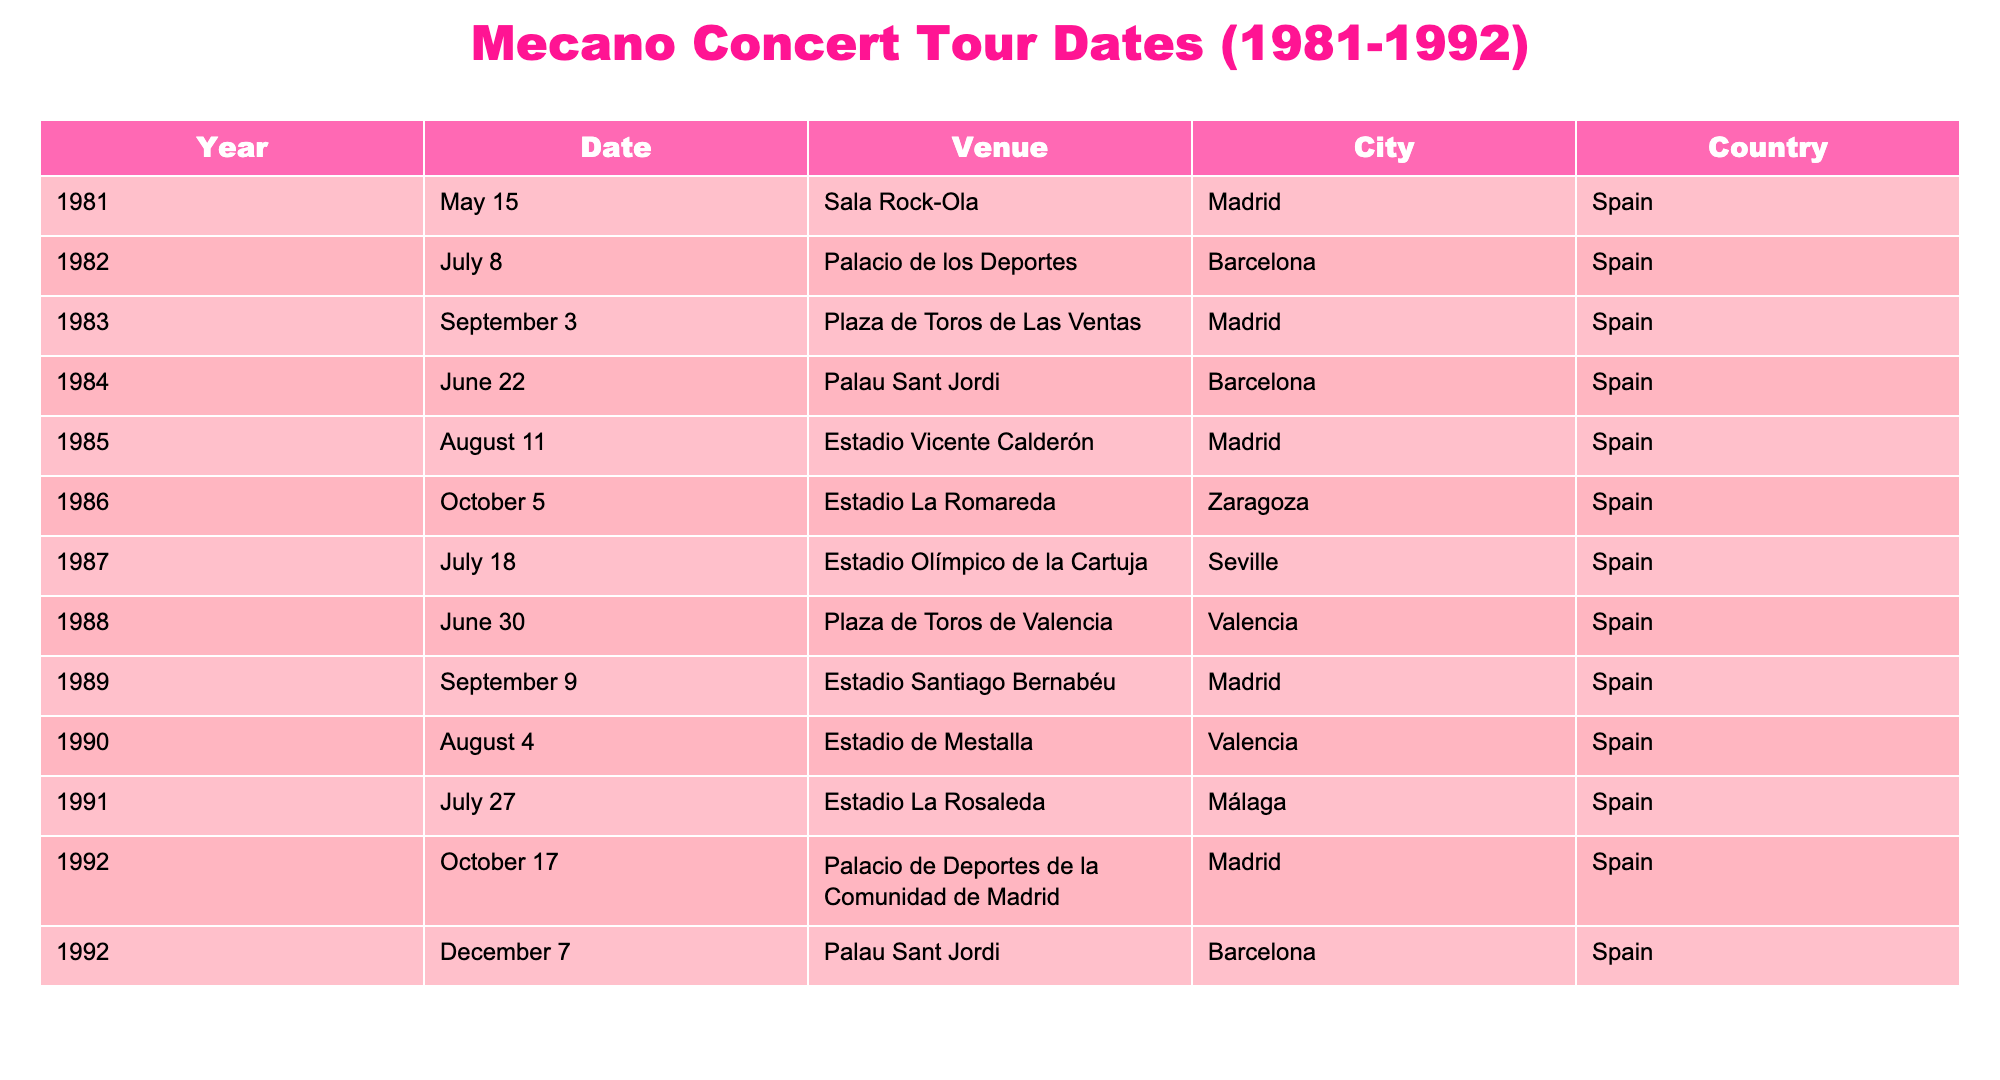What year did Mecano perform at Estadio Vicente Calderón? According to the table, Mecano performed at Estadio Vicente Calderón in 1985, as indicated in the row containing Venue details for that year.
Answer: 1985 Which city hosted the first concert in 1982? Referring to the table, the first concert in 1982 took place in Barcelona, as seen in the row for that year.
Answer: Barcelona How many concerts did Mecano have in Madrid from 1981 to 1992? By checking the table for rows that list Madrid as the city, we find concerts in 1981, 1983, 1985, 1989, and 1992, totaling five concerts.
Answer: 5 Did Mecano perform in Seville in 1987? Looking at the year 1987 in the table, it confirms that Mecano did indeed perform in Seville, as the entry for that year specifies the venue as Estadio Olímpico de la Cartuja in the city of Seville.
Answer: Yes What was the latest concert venue for Mecano in 1992? In the year 1992, the latest concert venue listed is Palacio de Deportes de la Comunidad de Madrid on October 17, making it the most recent concert venue for that year.
Answer: Palacio de Deportes de la Comunidad de Madrid On average, how many concerts did Mecano hold per year during this period? There are a total of 12 concerts from 1981 to 1992. The duration covers 12 years (1981 to 1992), so the average number of concerts per year is 12/12 = 1.
Answer: 1 Which concert venue had the highest number of concert appearances by Mecano? Analyzing the table, venues such as Madrid and Barcelona appear multiple times. Madrid has five concerts, and Barcelona has three, indicating that Estadio Santiago Bernabéu in Madrid is the venue with the highest appearances.
Answer: Estadio Santiago Bernabéu How many concerts did Mecano play in Valencia, and in which years? Checking the table reveals that Mecano had two concerts in Valencia—one in 1988 at Plaza de Toros de Valencia and another in 1990 at Estadio de Mestalla.
Answer: 2 concerts (1988, 1990) Which year saw Mecano performing more than once in Barcelona? The table shows that in December 1992, Mecano performed twice, once on October 17 at Palacio de Deportes de la Comunidad de Madrid and the other on December 7 at Palau Sant Jordi, which is the only year with multiple concerts in Barcelona.
Answer: 1992 